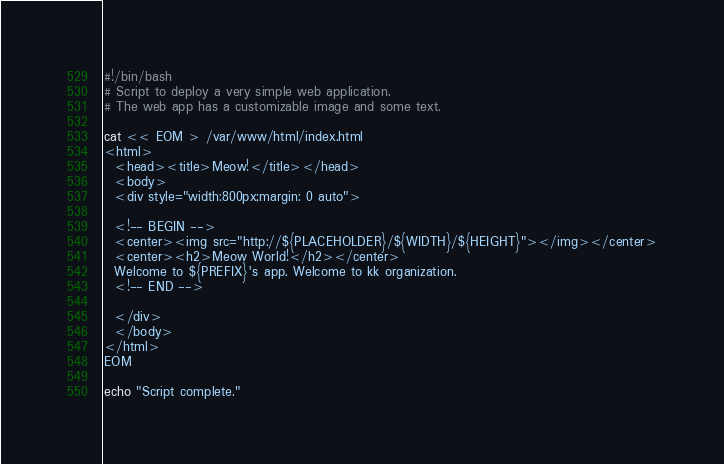<code> <loc_0><loc_0><loc_500><loc_500><_Bash_>#!/bin/bash
# Script to deploy a very simple web application.
# The web app has a customizable image and some text.

cat << EOM > /var/www/html/index.html
<html>
  <head><title>Meow!</title></head>
  <body>
  <div style="width:800px;margin: 0 auto">

  <!-- BEGIN -->
  <center><img src="http://${PLACEHOLDER}/${WIDTH}/${HEIGHT}"></img></center>
  <center><h2>Meow World!</h2></center>
  Welcome to ${PREFIX}'s app. Welcome to kk organization.
  <!-- END -->

  </div>
  </body>
</html>
EOM

echo "Script complete."
</code> 